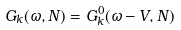Convert formula to latex. <formula><loc_0><loc_0><loc_500><loc_500>G _ { k } ( \omega , N ) = G _ { k } ^ { 0 } ( \omega - V , N )</formula> 